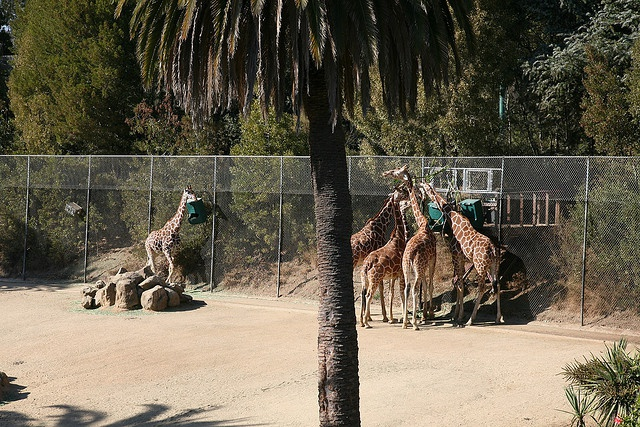Describe the objects in this image and their specific colors. I can see giraffe in gray, black, and maroon tones, giraffe in gray, black, and maroon tones, giraffe in gray, black, and maroon tones, giraffe in gray, lightgray, and black tones, and giraffe in gray, black, and maroon tones in this image. 